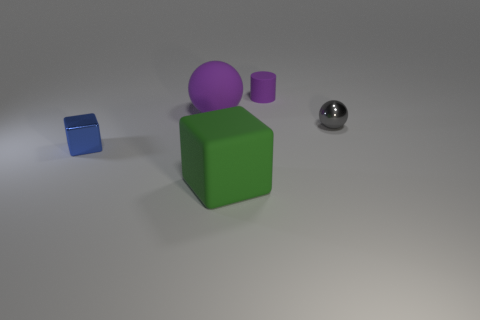Add 4 big red rubber cylinders. How many objects exist? 9 Subtract all cylinders. How many objects are left? 4 Add 2 big spheres. How many big spheres are left? 3 Add 3 metallic things. How many metallic things exist? 5 Subtract 0 red cylinders. How many objects are left? 5 Subtract all big yellow rubber cylinders. Subtract all big green matte blocks. How many objects are left? 4 